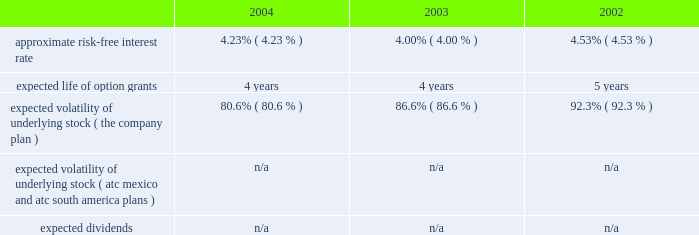American tower corporation and subsidiaries notes to consolidated financial statements 2014 ( continued ) pro forma disclosure 2014the company has adopted the disclosure-only provisions of sfas no .
123 , as amended by sfas no .
148 , and has presented such disclosure in note 1 .
The 201cfair value 201d of each option grant is estimated on the date of grant using the black-scholes option pricing model .
The weighted average fair values of the company 2019s options granted during 2004 , 2003 and 2002 were $ 7.05 , $ 6.32 , and $ 2.23 per share , respectively .
Key assumptions used to apply this pricing model are as follows: .
Voluntary option exchanges 2014in february 2004 , the company issued to eligible employees 1032717 options with an exercise price of $ 11.19 per share , the fair market value of the class a common stock on the date of grant .
These options were issued in connection with a voluntary option exchange program entered into by the company in august 2003 , where the company accepted for surrender and cancelled options ( having an exercise price of $ 10.25 or greater ) to purchase 1831981 shares of its class a common stock .
The program , which was offered to both full and part-time employees , excluding the company 2019s executive officers and its directors , called for the grant ( at least six months and one day from the surrender date to employees still employed on that date ) of new options exercisable for two shares of class a common stock for every three shares of class a common stock issuable upon exercise of a surrendered option .
No options were granted to any employees who participated in the exchange offer between the cancellation date and the new grant date .
In may 2002 , the company issued to eligible employees 2027612 options with an exercise price of $ 3.84 per share , the fair market value of the class a common stock on the date of grant .
These options were issued in connection with a voluntary option exchange program entered into by the company in october 2001 , where the company accepted for surrender and cancelled options to purchase 3471211 shares of its class a common stock .
The program , which was offered to both full and part-time employees , excluding most of the company 2019s executive officers , called for the grant ( at least six months and one day from the surrender date to employees still employed on that date ) of new options exercisable for two shares of class a common stock for every three shares of class a common stock issuable upon exercise of a surrendered option .
No options were granted to any employees who participated in the exchange offer between the cancellation date and the new grant date .
Atc mexico holding stock option plan 2014the company maintains a stock option plan in its atc mexico subsidiary ( atc mexico plan ) .
The atc mexico plan provides for the issuance of options to officers , employees , directors and consultants of atc mexico .
The atc mexico plan limits the number of shares of common stock which may be granted to an aggregate of 360 shares , subject to adjustment based on changes in atc mexico 2019s capital structure .
During 2002 , atc mexico granted options to purchase 318 shares of atc mexico common stock to officers and employees .
Such options were issued at one time with an exercise price of $ 10000 per share .
The exercise price per share was at fair market value as determined by the board of directors with the assistance of an independent appraisal performed at the company 2019s request .
The fair value of atc mexico plan options granted during 2002 were $ 3611 per share as determined by using the black-scholes option pricing model .
As described in note 10 , all outstanding options were exercised in march 2004 .
No options under the atc mexico plan were granted in 2004 or 2003 , or exercised or cancelled in 2003 or 2002 , and no options were exercisable as of december 31 , 2003 or 2002 .
( see note 10. ) .
What is the growth rate in weighted average fair values of the company 2019s options granted from 2003 to 2004? 
Computations: ((7.05 - 6.32) / 6.32)
Answer: 0.11551. 